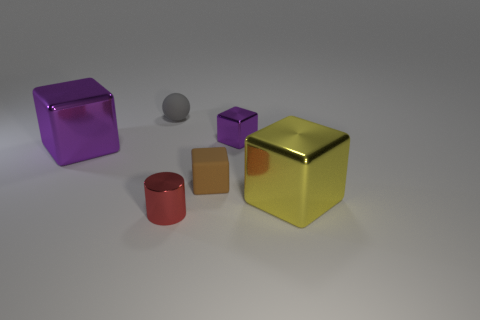Subtract all purple blocks. How many were subtracted if there are1purple blocks left? 1 Subtract all blue blocks. Subtract all red cylinders. How many blocks are left? 4 Add 1 purple cylinders. How many objects exist? 7 Subtract all cubes. How many objects are left? 2 Subtract all yellow metallic blocks. Subtract all metallic blocks. How many objects are left? 2 Add 5 purple cubes. How many purple cubes are left? 7 Add 1 blue things. How many blue things exist? 1 Subtract 0 cyan spheres. How many objects are left? 6 